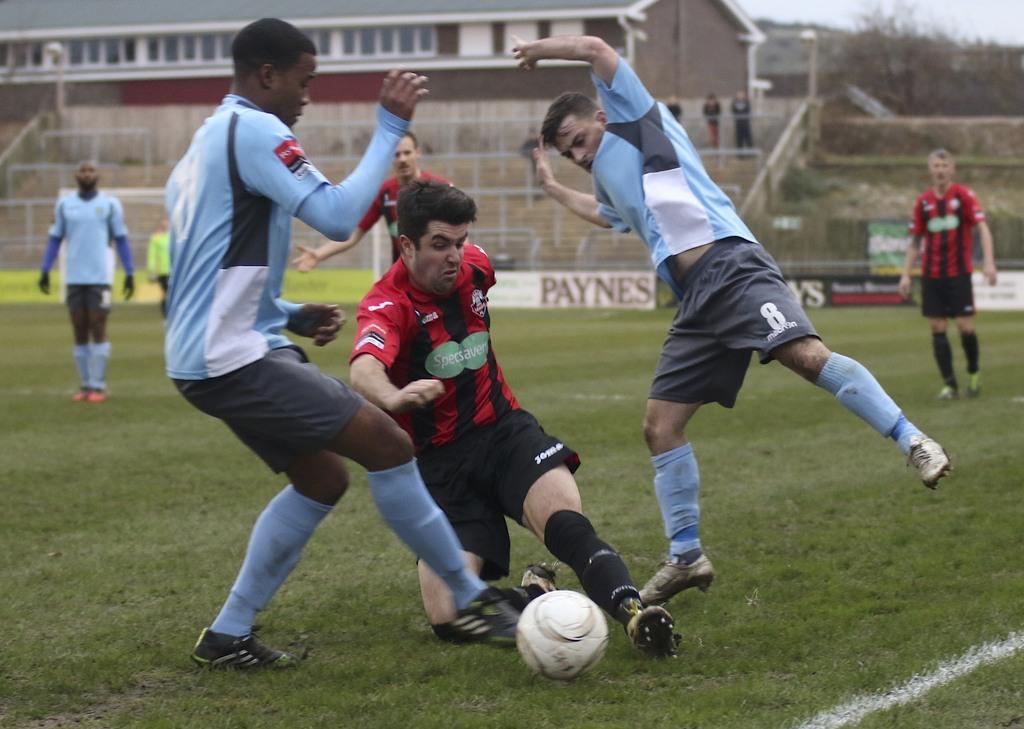Please provide a concise description of this image. Image is taken outside. Person at the middle of the image is wearing a black shirt, spikes and socks is trying to kick the ball. Left side there is a person wearing blue shirt and blue socks and shoe. There is a stairs at the backside of the image. Three persons is standing on the stairs. There are few trees and sky at the back. At the right side there is a person walking. Left side there is a person standing. 